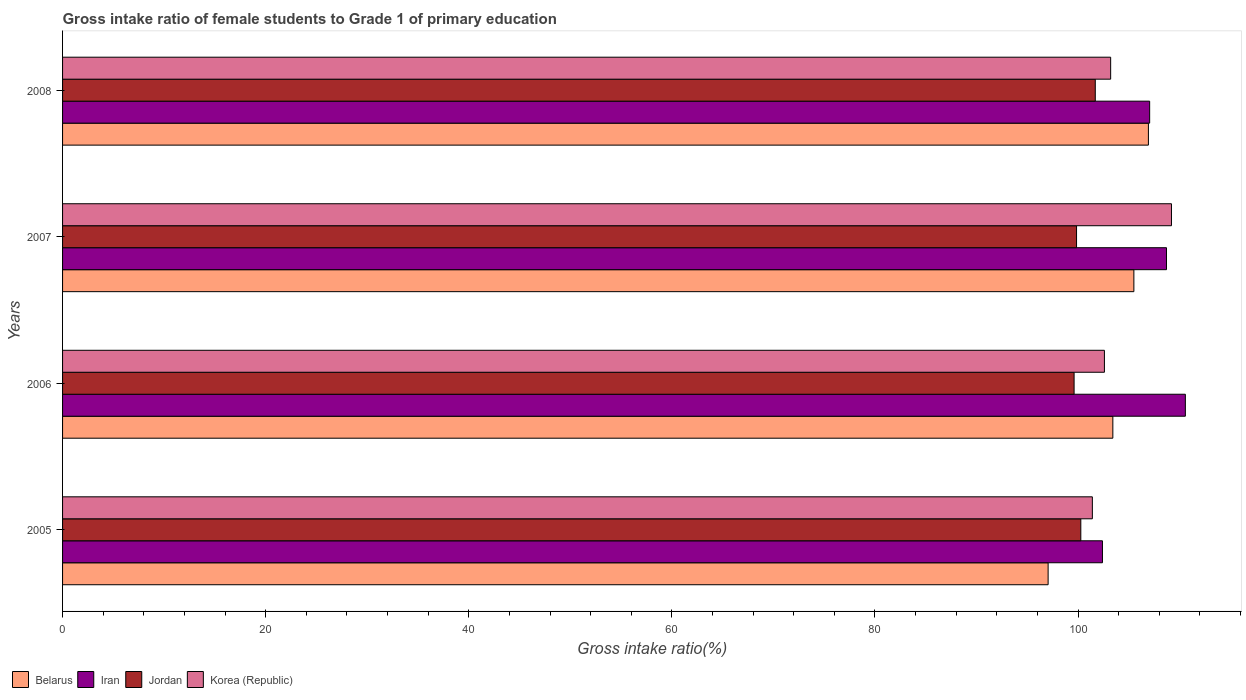Are the number of bars per tick equal to the number of legend labels?
Your answer should be compact. Yes. Are the number of bars on each tick of the Y-axis equal?
Your answer should be very brief. Yes. How many bars are there on the 2nd tick from the bottom?
Your response must be concise. 4. What is the label of the 4th group of bars from the top?
Your response must be concise. 2005. What is the gross intake ratio in Belarus in 2006?
Your response must be concise. 103.42. Across all years, what is the maximum gross intake ratio in Iran?
Give a very brief answer. 110.56. Across all years, what is the minimum gross intake ratio in Iran?
Provide a succinct answer. 102.4. What is the total gross intake ratio in Iran in the graph?
Ensure brevity in your answer.  428.72. What is the difference between the gross intake ratio in Jordan in 2006 and that in 2007?
Keep it short and to the point. -0.24. What is the difference between the gross intake ratio in Jordan in 2005 and the gross intake ratio in Belarus in 2008?
Offer a terse response. -6.66. What is the average gross intake ratio in Korea (Republic) per year?
Offer a terse response. 104.1. In the year 2005, what is the difference between the gross intake ratio in Jordan and gross intake ratio in Belarus?
Provide a short and direct response. 3.22. What is the ratio of the gross intake ratio in Iran in 2006 to that in 2007?
Make the answer very short. 1.02. Is the gross intake ratio in Iran in 2005 less than that in 2008?
Keep it short and to the point. Yes. Is the difference between the gross intake ratio in Jordan in 2007 and 2008 greater than the difference between the gross intake ratio in Belarus in 2007 and 2008?
Provide a short and direct response. No. What is the difference between the highest and the second highest gross intake ratio in Belarus?
Your answer should be compact. 1.43. What is the difference between the highest and the lowest gross intake ratio in Belarus?
Make the answer very short. 9.88. What does the 2nd bar from the top in 2005 represents?
Provide a succinct answer. Jordan. Is it the case that in every year, the sum of the gross intake ratio in Korea (Republic) and gross intake ratio in Iran is greater than the gross intake ratio in Belarus?
Offer a terse response. Yes. Are all the bars in the graph horizontal?
Your answer should be compact. Yes. Are the values on the major ticks of X-axis written in scientific E-notation?
Your answer should be compact. No. Does the graph contain any zero values?
Offer a terse response. No. Does the graph contain grids?
Provide a short and direct response. No. Where does the legend appear in the graph?
Your response must be concise. Bottom left. How many legend labels are there?
Provide a short and direct response. 4. What is the title of the graph?
Give a very brief answer. Gross intake ratio of female students to Grade 1 of primary education. Does "Montenegro" appear as one of the legend labels in the graph?
Give a very brief answer. No. What is the label or title of the X-axis?
Your response must be concise. Gross intake ratio(%). What is the label or title of the Y-axis?
Make the answer very short. Years. What is the Gross intake ratio(%) of Belarus in 2005?
Your answer should be compact. 97.05. What is the Gross intake ratio(%) in Iran in 2005?
Make the answer very short. 102.4. What is the Gross intake ratio(%) of Jordan in 2005?
Your response must be concise. 100.27. What is the Gross intake ratio(%) in Korea (Republic) in 2005?
Give a very brief answer. 101.41. What is the Gross intake ratio(%) in Belarus in 2006?
Keep it short and to the point. 103.42. What is the Gross intake ratio(%) of Iran in 2006?
Provide a short and direct response. 110.56. What is the Gross intake ratio(%) of Jordan in 2006?
Offer a very short reply. 99.61. What is the Gross intake ratio(%) in Korea (Republic) in 2006?
Your answer should be compact. 102.59. What is the Gross intake ratio(%) of Belarus in 2007?
Offer a very short reply. 105.5. What is the Gross intake ratio(%) in Iran in 2007?
Keep it short and to the point. 108.71. What is the Gross intake ratio(%) in Jordan in 2007?
Your answer should be compact. 99.85. What is the Gross intake ratio(%) of Korea (Republic) in 2007?
Ensure brevity in your answer.  109.2. What is the Gross intake ratio(%) of Belarus in 2008?
Your answer should be compact. 106.93. What is the Gross intake ratio(%) of Iran in 2008?
Give a very brief answer. 107.05. What is the Gross intake ratio(%) in Jordan in 2008?
Provide a short and direct response. 101.69. What is the Gross intake ratio(%) of Korea (Republic) in 2008?
Your response must be concise. 103.21. Across all years, what is the maximum Gross intake ratio(%) of Belarus?
Provide a succinct answer. 106.93. Across all years, what is the maximum Gross intake ratio(%) of Iran?
Make the answer very short. 110.56. Across all years, what is the maximum Gross intake ratio(%) of Jordan?
Offer a terse response. 101.69. Across all years, what is the maximum Gross intake ratio(%) of Korea (Republic)?
Provide a succinct answer. 109.2. Across all years, what is the minimum Gross intake ratio(%) of Belarus?
Provide a short and direct response. 97.05. Across all years, what is the minimum Gross intake ratio(%) in Iran?
Keep it short and to the point. 102.4. Across all years, what is the minimum Gross intake ratio(%) in Jordan?
Your answer should be compact. 99.61. Across all years, what is the minimum Gross intake ratio(%) in Korea (Republic)?
Ensure brevity in your answer.  101.41. What is the total Gross intake ratio(%) of Belarus in the graph?
Make the answer very short. 412.9. What is the total Gross intake ratio(%) in Iran in the graph?
Provide a succinct answer. 428.72. What is the total Gross intake ratio(%) of Jordan in the graph?
Your response must be concise. 401.42. What is the total Gross intake ratio(%) in Korea (Republic) in the graph?
Make the answer very short. 416.41. What is the difference between the Gross intake ratio(%) in Belarus in 2005 and that in 2006?
Provide a short and direct response. -6.37. What is the difference between the Gross intake ratio(%) in Iran in 2005 and that in 2006?
Give a very brief answer. -8.16. What is the difference between the Gross intake ratio(%) of Jordan in 2005 and that in 2006?
Your response must be concise. 0.66. What is the difference between the Gross intake ratio(%) of Korea (Republic) in 2005 and that in 2006?
Keep it short and to the point. -1.19. What is the difference between the Gross intake ratio(%) in Belarus in 2005 and that in 2007?
Make the answer very short. -8.44. What is the difference between the Gross intake ratio(%) of Iran in 2005 and that in 2007?
Offer a terse response. -6.31. What is the difference between the Gross intake ratio(%) of Jordan in 2005 and that in 2007?
Offer a terse response. 0.42. What is the difference between the Gross intake ratio(%) of Korea (Republic) in 2005 and that in 2007?
Provide a short and direct response. -7.79. What is the difference between the Gross intake ratio(%) of Belarus in 2005 and that in 2008?
Make the answer very short. -9.88. What is the difference between the Gross intake ratio(%) in Iran in 2005 and that in 2008?
Your answer should be compact. -4.65. What is the difference between the Gross intake ratio(%) in Jordan in 2005 and that in 2008?
Ensure brevity in your answer.  -1.43. What is the difference between the Gross intake ratio(%) in Korea (Republic) in 2005 and that in 2008?
Offer a terse response. -1.8. What is the difference between the Gross intake ratio(%) in Belarus in 2006 and that in 2007?
Keep it short and to the point. -2.07. What is the difference between the Gross intake ratio(%) of Iran in 2006 and that in 2007?
Offer a very short reply. 1.86. What is the difference between the Gross intake ratio(%) of Jordan in 2006 and that in 2007?
Keep it short and to the point. -0.24. What is the difference between the Gross intake ratio(%) in Korea (Republic) in 2006 and that in 2007?
Ensure brevity in your answer.  -6.6. What is the difference between the Gross intake ratio(%) of Belarus in 2006 and that in 2008?
Offer a terse response. -3.5. What is the difference between the Gross intake ratio(%) in Iran in 2006 and that in 2008?
Provide a short and direct response. 3.51. What is the difference between the Gross intake ratio(%) of Jordan in 2006 and that in 2008?
Provide a short and direct response. -2.09. What is the difference between the Gross intake ratio(%) of Korea (Republic) in 2006 and that in 2008?
Keep it short and to the point. -0.61. What is the difference between the Gross intake ratio(%) in Belarus in 2007 and that in 2008?
Provide a short and direct response. -1.43. What is the difference between the Gross intake ratio(%) of Iran in 2007 and that in 2008?
Provide a succinct answer. 1.66. What is the difference between the Gross intake ratio(%) in Jordan in 2007 and that in 2008?
Your response must be concise. -1.84. What is the difference between the Gross intake ratio(%) of Korea (Republic) in 2007 and that in 2008?
Provide a short and direct response. 5.99. What is the difference between the Gross intake ratio(%) of Belarus in 2005 and the Gross intake ratio(%) of Iran in 2006?
Provide a succinct answer. -13.51. What is the difference between the Gross intake ratio(%) in Belarus in 2005 and the Gross intake ratio(%) in Jordan in 2006?
Provide a succinct answer. -2.56. What is the difference between the Gross intake ratio(%) of Belarus in 2005 and the Gross intake ratio(%) of Korea (Republic) in 2006?
Provide a succinct answer. -5.54. What is the difference between the Gross intake ratio(%) of Iran in 2005 and the Gross intake ratio(%) of Jordan in 2006?
Offer a very short reply. 2.79. What is the difference between the Gross intake ratio(%) in Iran in 2005 and the Gross intake ratio(%) in Korea (Republic) in 2006?
Your answer should be very brief. -0.19. What is the difference between the Gross intake ratio(%) in Jordan in 2005 and the Gross intake ratio(%) in Korea (Republic) in 2006?
Your answer should be compact. -2.33. What is the difference between the Gross intake ratio(%) of Belarus in 2005 and the Gross intake ratio(%) of Iran in 2007?
Your response must be concise. -11.66. What is the difference between the Gross intake ratio(%) of Belarus in 2005 and the Gross intake ratio(%) of Jordan in 2007?
Your response must be concise. -2.8. What is the difference between the Gross intake ratio(%) in Belarus in 2005 and the Gross intake ratio(%) in Korea (Republic) in 2007?
Offer a terse response. -12.15. What is the difference between the Gross intake ratio(%) of Iran in 2005 and the Gross intake ratio(%) of Jordan in 2007?
Provide a short and direct response. 2.55. What is the difference between the Gross intake ratio(%) of Iran in 2005 and the Gross intake ratio(%) of Korea (Republic) in 2007?
Offer a terse response. -6.8. What is the difference between the Gross intake ratio(%) in Jordan in 2005 and the Gross intake ratio(%) in Korea (Republic) in 2007?
Your answer should be very brief. -8.93. What is the difference between the Gross intake ratio(%) in Belarus in 2005 and the Gross intake ratio(%) in Iran in 2008?
Give a very brief answer. -10. What is the difference between the Gross intake ratio(%) in Belarus in 2005 and the Gross intake ratio(%) in Jordan in 2008?
Offer a terse response. -4.64. What is the difference between the Gross intake ratio(%) of Belarus in 2005 and the Gross intake ratio(%) of Korea (Republic) in 2008?
Offer a very short reply. -6.16. What is the difference between the Gross intake ratio(%) in Iran in 2005 and the Gross intake ratio(%) in Jordan in 2008?
Keep it short and to the point. 0.71. What is the difference between the Gross intake ratio(%) of Iran in 2005 and the Gross intake ratio(%) of Korea (Republic) in 2008?
Provide a succinct answer. -0.81. What is the difference between the Gross intake ratio(%) of Jordan in 2005 and the Gross intake ratio(%) of Korea (Republic) in 2008?
Your answer should be compact. -2.94. What is the difference between the Gross intake ratio(%) of Belarus in 2006 and the Gross intake ratio(%) of Iran in 2007?
Your response must be concise. -5.28. What is the difference between the Gross intake ratio(%) of Belarus in 2006 and the Gross intake ratio(%) of Jordan in 2007?
Offer a terse response. 3.58. What is the difference between the Gross intake ratio(%) in Belarus in 2006 and the Gross intake ratio(%) in Korea (Republic) in 2007?
Your answer should be compact. -5.77. What is the difference between the Gross intake ratio(%) of Iran in 2006 and the Gross intake ratio(%) of Jordan in 2007?
Give a very brief answer. 10.71. What is the difference between the Gross intake ratio(%) in Iran in 2006 and the Gross intake ratio(%) in Korea (Republic) in 2007?
Offer a terse response. 1.37. What is the difference between the Gross intake ratio(%) of Jordan in 2006 and the Gross intake ratio(%) of Korea (Republic) in 2007?
Make the answer very short. -9.59. What is the difference between the Gross intake ratio(%) of Belarus in 2006 and the Gross intake ratio(%) of Iran in 2008?
Make the answer very short. -3.62. What is the difference between the Gross intake ratio(%) of Belarus in 2006 and the Gross intake ratio(%) of Jordan in 2008?
Your answer should be compact. 1.73. What is the difference between the Gross intake ratio(%) in Belarus in 2006 and the Gross intake ratio(%) in Korea (Republic) in 2008?
Make the answer very short. 0.22. What is the difference between the Gross intake ratio(%) in Iran in 2006 and the Gross intake ratio(%) in Jordan in 2008?
Your response must be concise. 8.87. What is the difference between the Gross intake ratio(%) in Iran in 2006 and the Gross intake ratio(%) in Korea (Republic) in 2008?
Your answer should be compact. 7.36. What is the difference between the Gross intake ratio(%) of Jordan in 2006 and the Gross intake ratio(%) of Korea (Republic) in 2008?
Keep it short and to the point. -3.6. What is the difference between the Gross intake ratio(%) of Belarus in 2007 and the Gross intake ratio(%) of Iran in 2008?
Offer a terse response. -1.55. What is the difference between the Gross intake ratio(%) of Belarus in 2007 and the Gross intake ratio(%) of Jordan in 2008?
Provide a succinct answer. 3.8. What is the difference between the Gross intake ratio(%) of Belarus in 2007 and the Gross intake ratio(%) of Korea (Republic) in 2008?
Your response must be concise. 2.29. What is the difference between the Gross intake ratio(%) of Iran in 2007 and the Gross intake ratio(%) of Jordan in 2008?
Offer a very short reply. 7.01. What is the difference between the Gross intake ratio(%) in Iran in 2007 and the Gross intake ratio(%) in Korea (Republic) in 2008?
Your response must be concise. 5.5. What is the difference between the Gross intake ratio(%) of Jordan in 2007 and the Gross intake ratio(%) of Korea (Republic) in 2008?
Offer a very short reply. -3.36. What is the average Gross intake ratio(%) in Belarus per year?
Your answer should be very brief. 103.22. What is the average Gross intake ratio(%) of Iran per year?
Make the answer very short. 107.18. What is the average Gross intake ratio(%) in Jordan per year?
Provide a short and direct response. 100.35. What is the average Gross intake ratio(%) of Korea (Republic) per year?
Offer a very short reply. 104.1. In the year 2005, what is the difference between the Gross intake ratio(%) in Belarus and Gross intake ratio(%) in Iran?
Your answer should be compact. -5.35. In the year 2005, what is the difference between the Gross intake ratio(%) of Belarus and Gross intake ratio(%) of Jordan?
Provide a succinct answer. -3.22. In the year 2005, what is the difference between the Gross intake ratio(%) in Belarus and Gross intake ratio(%) in Korea (Republic)?
Offer a very short reply. -4.36. In the year 2005, what is the difference between the Gross intake ratio(%) of Iran and Gross intake ratio(%) of Jordan?
Give a very brief answer. 2.13. In the year 2005, what is the difference between the Gross intake ratio(%) of Iran and Gross intake ratio(%) of Korea (Republic)?
Make the answer very short. 0.99. In the year 2005, what is the difference between the Gross intake ratio(%) in Jordan and Gross intake ratio(%) in Korea (Republic)?
Keep it short and to the point. -1.14. In the year 2006, what is the difference between the Gross intake ratio(%) of Belarus and Gross intake ratio(%) of Iran?
Provide a succinct answer. -7.14. In the year 2006, what is the difference between the Gross intake ratio(%) in Belarus and Gross intake ratio(%) in Jordan?
Keep it short and to the point. 3.82. In the year 2006, what is the difference between the Gross intake ratio(%) in Belarus and Gross intake ratio(%) in Korea (Republic)?
Your answer should be very brief. 0.83. In the year 2006, what is the difference between the Gross intake ratio(%) of Iran and Gross intake ratio(%) of Jordan?
Make the answer very short. 10.96. In the year 2006, what is the difference between the Gross intake ratio(%) in Iran and Gross intake ratio(%) in Korea (Republic)?
Provide a succinct answer. 7.97. In the year 2006, what is the difference between the Gross intake ratio(%) of Jordan and Gross intake ratio(%) of Korea (Republic)?
Make the answer very short. -2.99. In the year 2007, what is the difference between the Gross intake ratio(%) in Belarus and Gross intake ratio(%) in Iran?
Offer a terse response. -3.21. In the year 2007, what is the difference between the Gross intake ratio(%) of Belarus and Gross intake ratio(%) of Jordan?
Your response must be concise. 5.65. In the year 2007, what is the difference between the Gross intake ratio(%) of Belarus and Gross intake ratio(%) of Korea (Republic)?
Your answer should be compact. -3.7. In the year 2007, what is the difference between the Gross intake ratio(%) of Iran and Gross intake ratio(%) of Jordan?
Offer a very short reply. 8.86. In the year 2007, what is the difference between the Gross intake ratio(%) of Iran and Gross intake ratio(%) of Korea (Republic)?
Your answer should be compact. -0.49. In the year 2007, what is the difference between the Gross intake ratio(%) of Jordan and Gross intake ratio(%) of Korea (Republic)?
Give a very brief answer. -9.35. In the year 2008, what is the difference between the Gross intake ratio(%) in Belarus and Gross intake ratio(%) in Iran?
Your answer should be very brief. -0.12. In the year 2008, what is the difference between the Gross intake ratio(%) of Belarus and Gross intake ratio(%) of Jordan?
Make the answer very short. 5.23. In the year 2008, what is the difference between the Gross intake ratio(%) of Belarus and Gross intake ratio(%) of Korea (Republic)?
Ensure brevity in your answer.  3.72. In the year 2008, what is the difference between the Gross intake ratio(%) of Iran and Gross intake ratio(%) of Jordan?
Provide a short and direct response. 5.36. In the year 2008, what is the difference between the Gross intake ratio(%) of Iran and Gross intake ratio(%) of Korea (Republic)?
Your answer should be very brief. 3.84. In the year 2008, what is the difference between the Gross intake ratio(%) in Jordan and Gross intake ratio(%) in Korea (Republic)?
Keep it short and to the point. -1.51. What is the ratio of the Gross intake ratio(%) of Belarus in 2005 to that in 2006?
Offer a very short reply. 0.94. What is the ratio of the Gross intake ratio(%) of Iran in 2005 to that in 2006?
Provide a succinct answer. 0.93. What is the ratio of the Gross intake ratio(%) in Jordan in 2005 to that in 2006?
Ensure brevity in your answer.  1.01. What is the ratio of the Gross intake ratio(%) of Korea (Republic) in 2005 to that in 2006?
Provide a succinct answer. 0.99. What is the ratio of the Gross intake ratio(%) in Iran in 2005 to that in 2007?
Ensure brevity in your answer.  0.94. What is the ratio of the Gross intake ratio(%) of Korea (Republic) in 2005 to that in 2007?
Offer a terse response. 0.93. What is the ratio of the Gross intake ratio(%) in Belarus in 2005 to that in 2008?
Offer a terse response. 0.91. What is the ratio of the Gross intake ratio(%) in Iran in 2005 to that in 2008?
Your response must be concise. 0.96. What is the ratio of the Gross intake ratio(%) in Jordan in 2005 to that in 2008?
Make the answer very short. 0.99. What is the ratio of the Gross intake ratio(%) of Korea (Republic) in 2005 to that in 2008?
Your answer should be compact. 0.98. What is the ratio of the Gross intake ratio(%) of Belarus in 2006 to that in 2007?
Provide a short and direct response. 0.98. What is the ratio of the Gross intake ratio(%) in Iran in 2006 to that in 2007?
Your response must be concise. 1.02. What is the ratio of the Gross intake ratio(%) of Korea (Republic) in 2006 to that in 2007?
Keep it short and to the point. 0.94. What is the ratio of the Gross intake ratio(%) of Belarus in 2006 to that in 2008?
Your response must be concise. 0.97. What is the ratio of the Gross intake ratio(%) of Iran in 2006 to that in 2008?
Your response must be concise. 1.03. What is the ratio of the Gross intake ratio(%) in Jordan in 2006 to that in 2008?
Your answer should be compact. 0.98. What is the ratio of the Gross intake ratio(%) in Belarus in 2007 to that in 2008?
Your answer should be compact. 0.99. What is the ratio of the Gross intake ratio(%) of Iran in 2007 to that in 2008?
Ensure brevity in your answer.  1.02. What is the ratio of the Gross intake ratio(%) in Jordan in 2007 to that in 2008?
Give a very brief answer. 0.98. What is the ratio of the Gross intake ratio(%) in Korea (Republic) in 2007 to that in 2008?
Offer a very short reply. 1.06. What is the difference between the highest and the second highest Gross intake ratio(%) in Belarus?
Offer a terse response. 1.43. What is the difference between the highest and the second highest Gross intake ratio(%) in Iran?
Keep it short and to the point. 1.86. What is the difference between the highest and the second highest Gross intake ratio(%) in Jordan?
Provide a short and direct response. 1.43. What is the difference between the highest and the second highest Gross intake ratio(%) of Korea (Republic)?
Keep it short and to the point. 5.99. What is the difference between the highest and the lowest Gross intake ratio(%) of Belarus?
Your response must be concise. 9.88. What is the difference between the highest and the lowest Gross intake ratio(%) of Iran?
Offer a terse response. 8.16. What is the difference between the highest and the lowest Gross intake ratio(%) of Jordan?
Offer a very short reply. 2.09. What is the difference between the highest and the lowest Gross intake ratio(%) in Korea (Republic)?
Give a very brief answer. 7.79. 